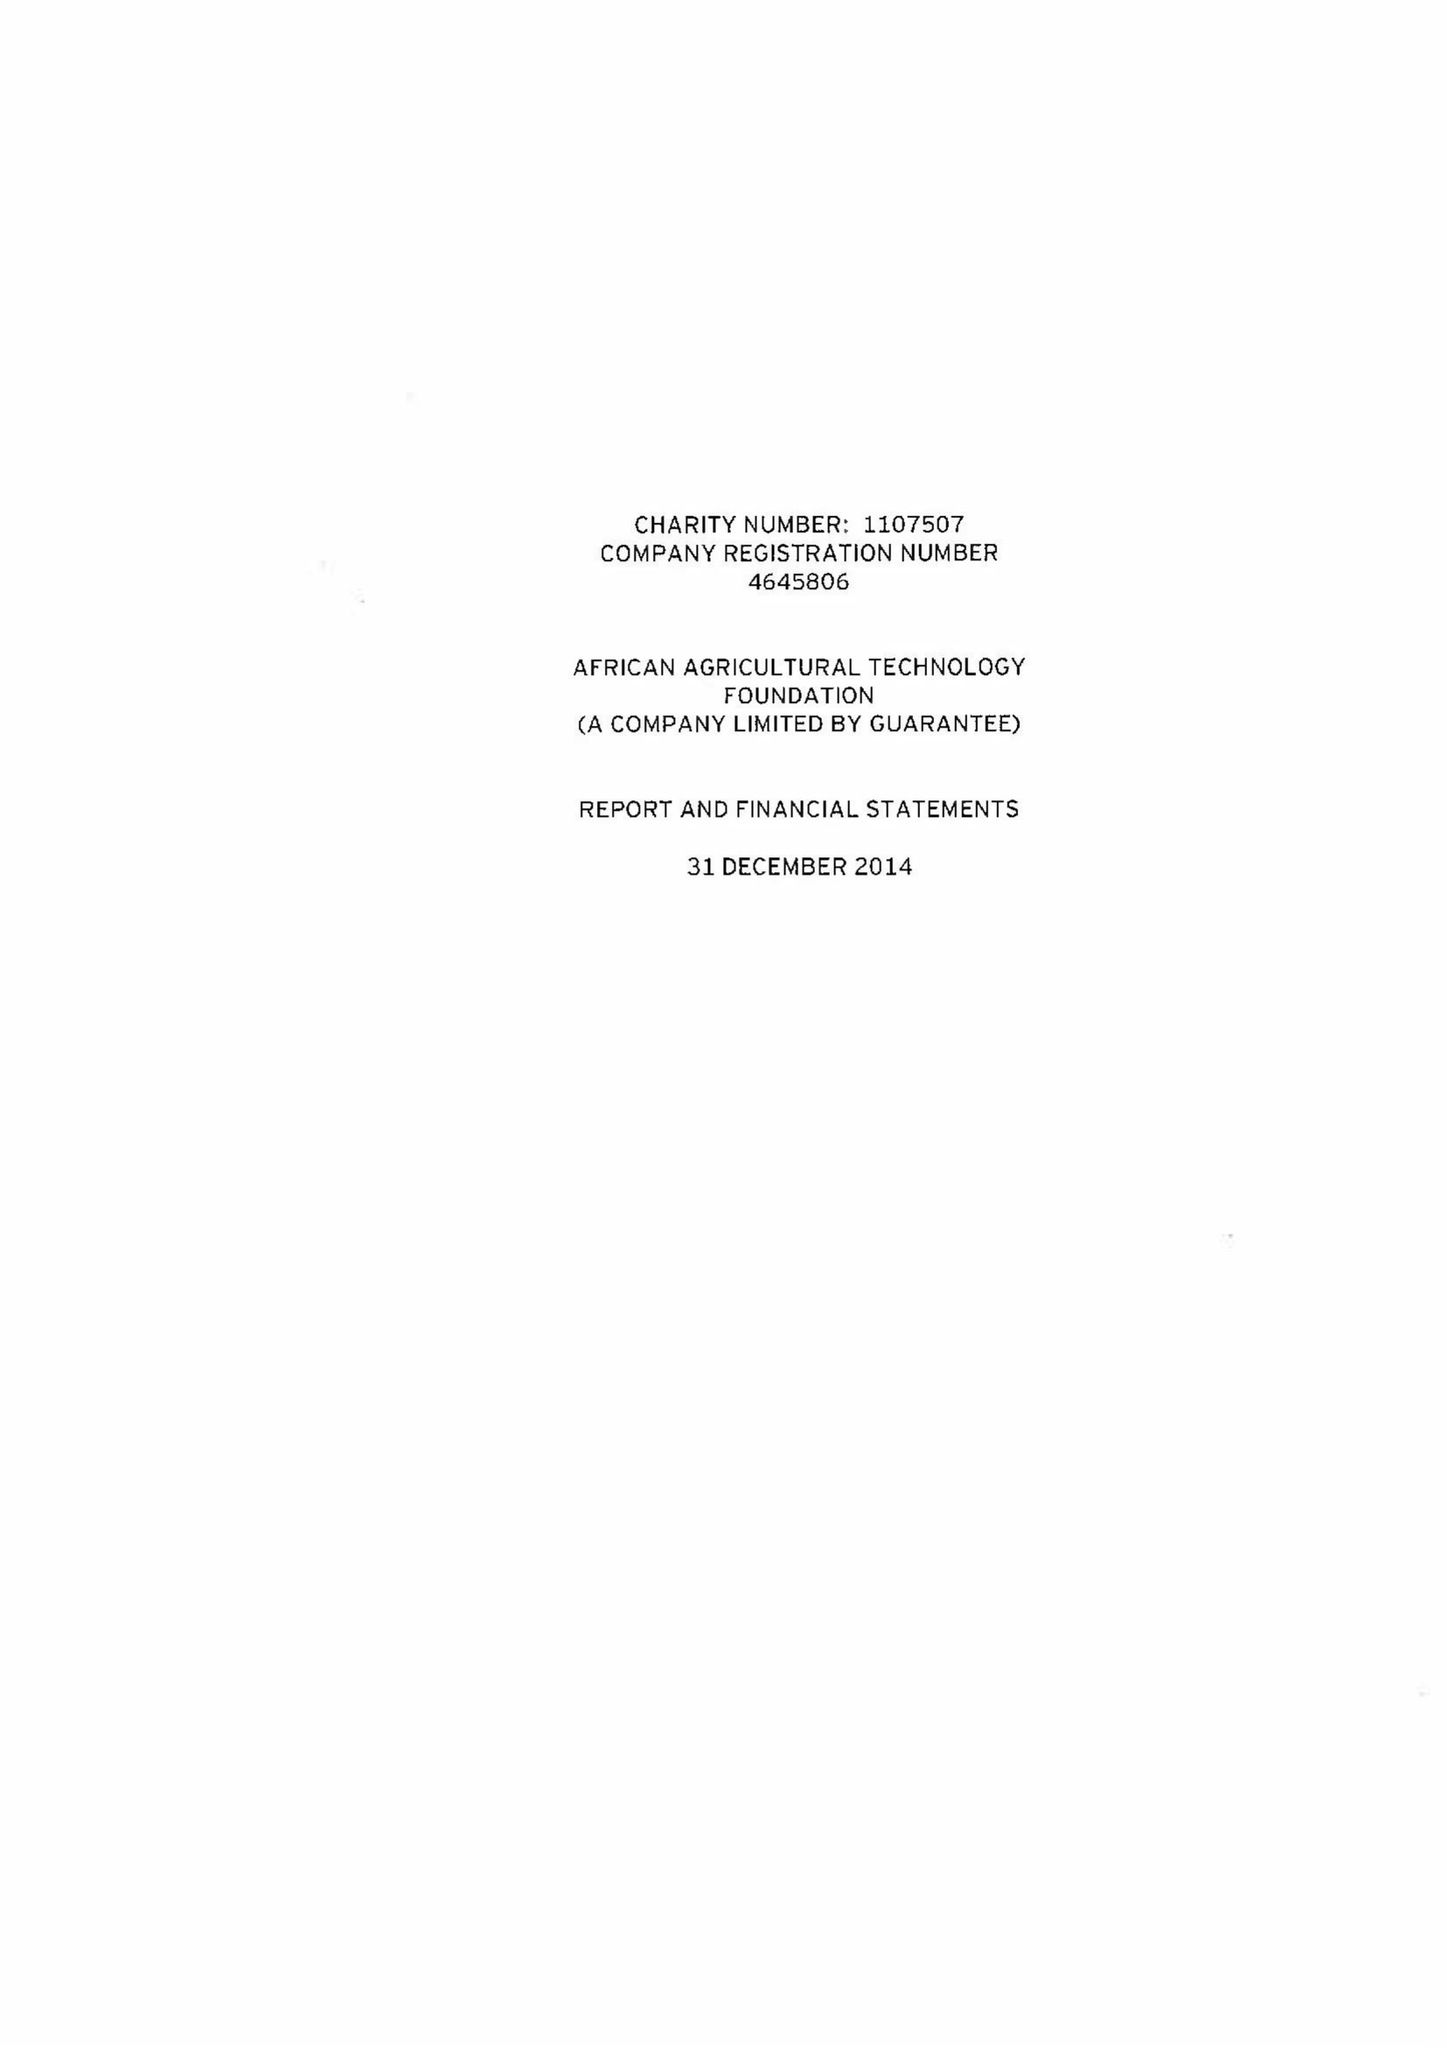What is the value for the charity_number?
Answer the question using a single word or phrase. 1107507 